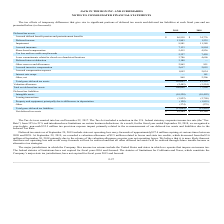According to Jack In The Box's financial document, When was the Tax Act enacted into law? According to the financial document, December 22, 2017. The relevant text states: "The Tax Act was enacted into law on December 22, 2017. The Tax Act included a reduction in the U.S. federal statutory corporate income tax rate (the “Tax..." Also, Why was there a decrease of valuation allowance from 2018 to 2019? Due to the release of the valuation allowance on prior year net operating losses. The document states: "the $3.6 million at September 30, 2018 primarily due to the release of the valuation allowance on prior year net operating losses. We believe that it ..." Also, What was the net deferred tax assets in 2019? According to the financial document, $85,564 (in thousands). The relevant text states: "Net deferred tax assets $ 85,564 $ 62,140..." Also, can you calculate: What is the difference in net deferred tax assets between 2018 and 2019? Based on the calculation: $85,564-$62,140, the result is 23424 (in thousands). This is based on the information: "Net deferred tax assets $ 85,564 $ 62,140 Net deferred tax assets $ 85,564 $ 62,140..." The key data points involved are: 62,140, 85,564. Also, can you calculate: What is the average total gross deferred tax assets for 2018 and 2019? To answer this question, I need to perform calculations using the financial data. The calculation is: (103,093+81,110)/2, which equals 92101.5 (in thousands). This is based on the information: "Total gross deferred tax assets 103,093 81,110 Total gross deferred tax assets 103,093 81,110..." The key data points involved are: 103,093, 81,110. Also, can you calculate: What is the percentage change in accrued incentive compensation from 2018 to 2019? To answer this question, I need to perform calculations using the financial data. The calculation is: (2,617-2,055)/2,055, which equals 27.35 (percentage). This is based on the information: "Accrued incentive compensation 2,617 2,055 Accrued incentive compensation 2,617 2,055..." The key data points involved are: 2,055, 2,617. 